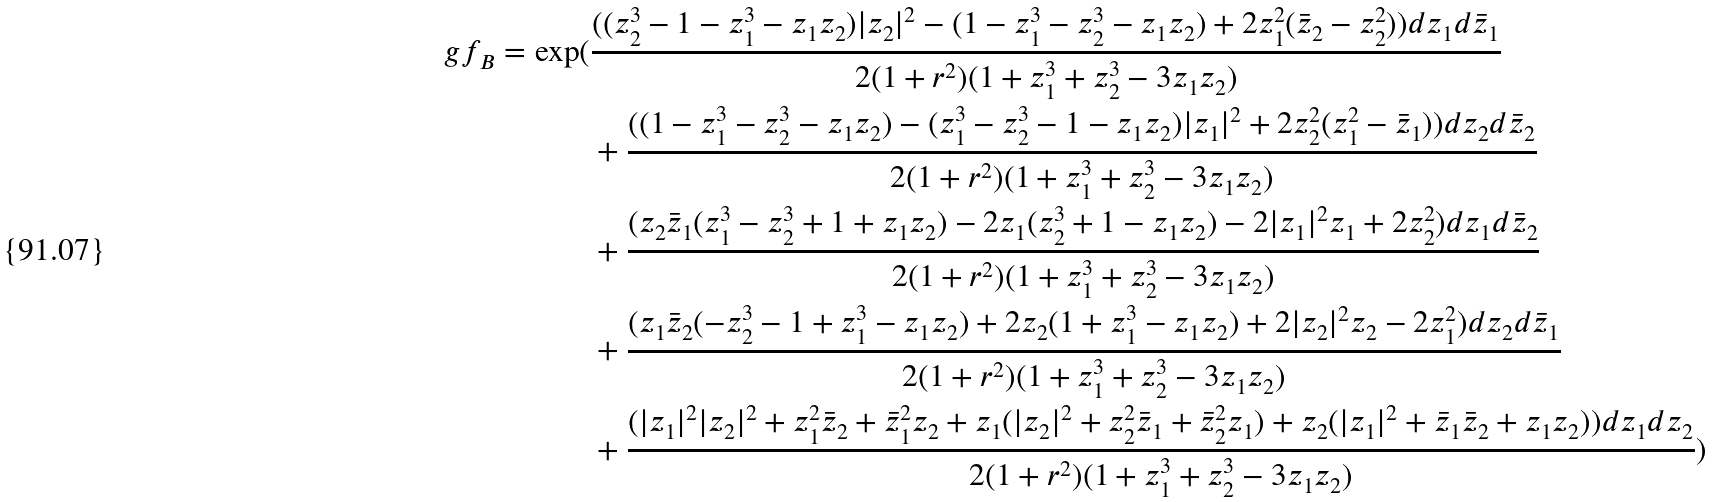Convert formula to latex. <formula><loc_0><loc_0><loc_500><loc_500>\ g f _ { B } = \exp ( & \frac { ( ( z _ { 2 } ^ { 3 } - 1 - z _ { 1 } ^ { 3 } - z _ { 1 } z _ { 2 } ) | z _ { 2 } | ^ { 2 } - ( 1 - z _ { 1 } ^ { 3 } - z _ { 2 } ^ { 3 } - z _ { 1 } z _ { 2 } ) + 2 z _ { 1 } ^ { 2 } ( \bar { z } _ { 2 } - z _ { 2 } ^ { 2 } ) ) d z _ { 1 } d \bar { z } _ { 1 } } { 2 ( 1 + r ^ { 2 } ) ( 1 + z _ { 1 } ^ { 3 } + z _ { 2 } ^ { 3 } - 3 z _ { 1 } z _ { 2 } ) } \\ & + \frac { ( ( 1 - z _ { 1 } ^ { 3 } - z _ { 2 } ^ { 3 } - z _ { 1 } z _ { 2 } ) - ( z _ { 1 } ^ { 3 } - z _ { 2 } ^ { 3 } - 1 - z _ { 1 } z _ { 2 } ) | z _ { 1 } | ^ { 2 } + 2 z _ { 2 } ^ { 2 } ( z _ { 1 } ^ { 2 } - \bar { z } _ { 1 } ) ) d z _ { 2 } d \bar { z } _ { 2 } } { 2 ( 1 + r ^ { 2 } ) ( 1 + z _ { 1 } ^ { 3 } + z _ { 2 } ^ { 3 } - 3 z _ { 1 } z _ { 2 } ) } \\ & + \frac { ( z _ { 2 } \bar { z } _ { 1 } ( z _ { 1 } ^ { 3 } - z _ { 2 } ^ { 3 } + 1 + z _ { 1 } z _ { 2 } ) - 2 z _ { 1 } ( z _ { 2 } ^ { 3 } + 1 - z _ { 1 } z _ { 2 } ) - 2 | z _ { 1 } | ^ { 2 } z _ { 1 } + 2 z _ { 2 } ^ { 2 } ) d z _ { 1 } d \bar { z } _ { 2 } } { 2 ( 1 + r ^ { 2 } ) ( 1 + z _ { 1 } ^ { 3 } + z _ { 2 } ^ { 3 } - 3 z _ { 1 } z _ { 2 } ) } \\ & + \frac { ( z _ { 1 } \bar { z } _ { 2 } ( - z _ { 2 } ^ { 3 } - 1 + z _ { 1 } ^ { 3 } - z _ { 1 } z _ { 2 } ) + 2 z _ { 2 } ( 1 + z _ { 1 } ^ { 3 } - z _ { 1 } z _ { 2 } ) + 2 | z _ { 2 } | ^ { 2 } z _ { 2 } - 2 z _ { 1 } ^ { 2 } ) d z _ { 2 } d \bar { z } _ { 1 } } { 2 ( 1 + r ^ { 2 } ) ( 1 + z _ { 1 } ^ { 3 } + z _ { 2 } ^ { 3 } - 3 z _ { 1 } z _ { 2 } ) } \\ & + \frac { ( | z _ { 1 } | ^ { 2 } | z _ { 2 } | ^ { 2 } + z _ { 1 } ^ { 2 } \bar { z } _ { 2 } + \bar { z } _ { 1 } ^ { 2 } z _ { 2 } + z _ { 1 } ( | z _ { 2 } | ^ { 2 } + z _ { 2 } ^ { 2 } \bar { z } _ { 1 } + \bar { z } _ { 2 } ^ { 2 } z _ { 1 } ) + z _ { 2 } ( | z _ { 1 } | ^ { 2 } + \bar { z } _ { 1 } \bar { z } _ { 2 } + z _ { 1 } z _ { 2 } ) ) d z _ { 1 } d z _ { 2 } } { 2 ( 1 + r ^ { 2 } ) ( 1 + z _ { 1 } ^ { 3 } + z _ { 2 } ^ { 3 } - 3 z _ { 1 } z _ { 2 } ) } )</formula> 